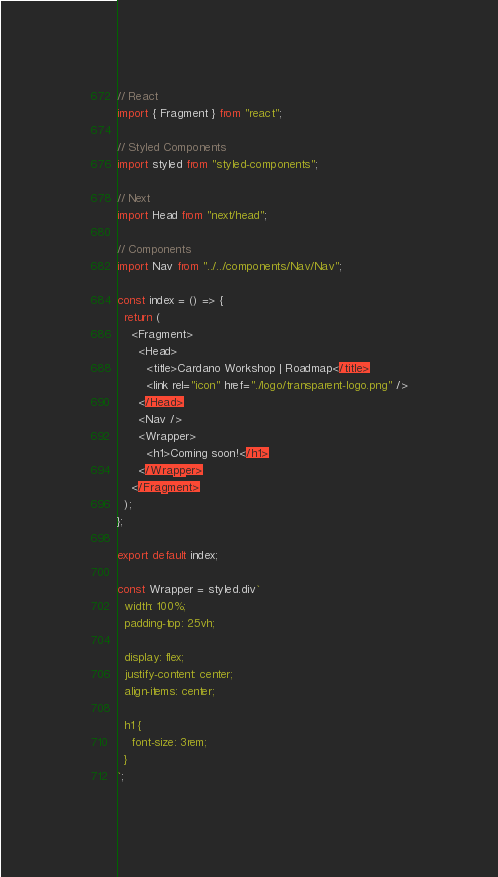Convert code to text. <code><loc_0><loc_0><loc_500><loc_500><_JavaScript_>// React
import { Fragment } from "react";

// Styled Components
import styled from "styled-components";

// Next
import Head from "next/head";

// Components
import Nav from "../../components/Nav/Nav";

const index = () => {
  return (
    <Fragment>
      <Head>
        <title>Cardano Workshop | Roadmap</title>
        <link rel="icon" href="./logo/transparent-logo.png" />
      </Head>
      <Nav />
      <Wrapper>
        <h1>Coming soon!</h1>
      </Wrapper>
    </Fragment>
  );
};

export default index;

const Wrapper = styled.div`
  width: 100%;
  padding-top: 25vh;

  display: flex;
  justify-content: center;
  align-items: center;

  h1 {
    font-size: 3rem;
  }
`;
</code> 